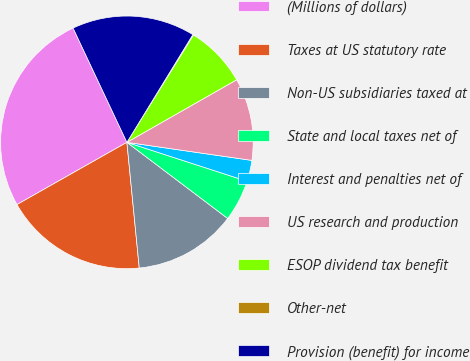<chart> <loc_0><loc_0><loc_500><loc_500><pie_chart><fcel>(Millions of dollars)<fcel>Taxes at US statutory rate<fcel>Non-US subsidiaries taxed at<fcel>State and local taxes net of<fcel>Interest and penalties net of<fcel>US research and production<fcel>ESOP dividend tax benefit<fcel>Other-net<fcel>Provision (benefit) for income<nl><fcel>26.19%<fcel>18.36%<fcel>13.14%<fcel>5.31%<fcel>2.7%<fcel>10.53%<fcel>7.92%<fcel>0.09%<fcel>15.75%<nl></chart> 